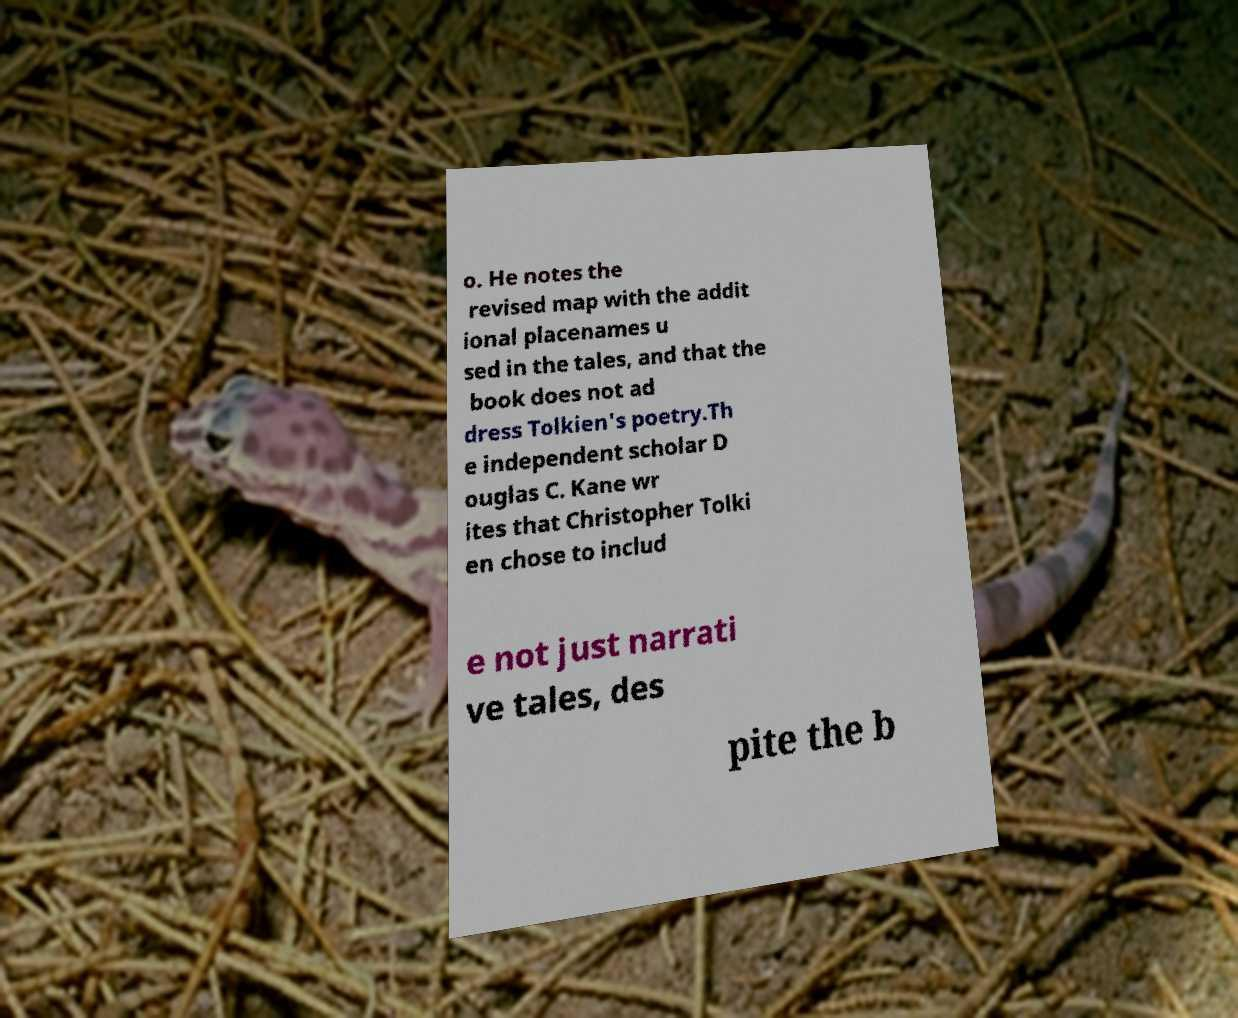Please identify and transcribe the text found in this image. o. He notes the revised map with the addit ional placenames u sed in the tales, and that the book does not ad dress Tolkien's poetry.Th e independent scholar D ouglas C. Kane wr ites that Christopher Tolki en chose to includ e not just narrati ve tales, des pite the b 